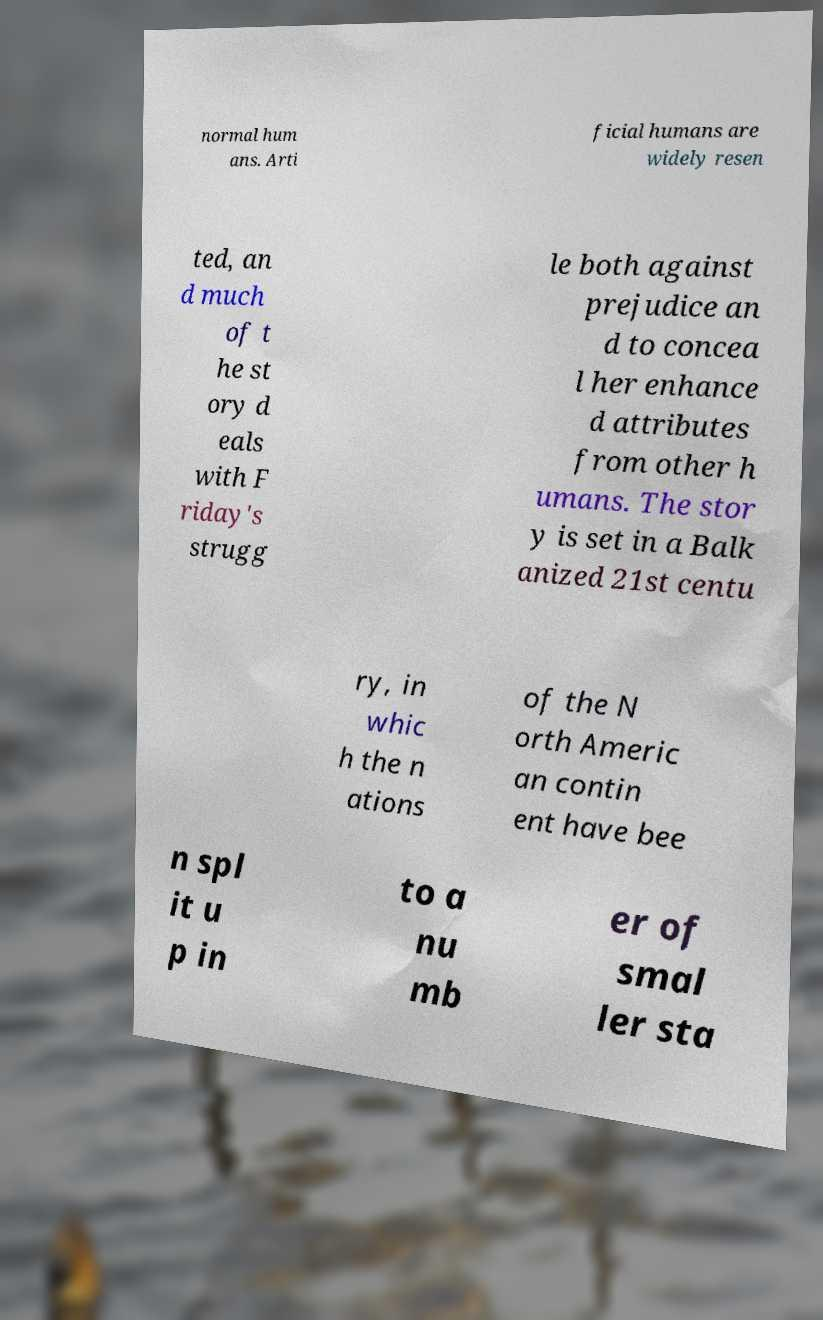Can you read and provide the text displayed in the image?This photo seems to have some interesting text. Can you extract and type it out for me? normal hum ans. Arti ficial humans are widely resen ted, an d much of t he st ory d eals with F riday's strugg le both against prejudice an d to concea l her enhance d attributes from other h umans. The stor y is set in a Balk anized 21st centu ry, in whic h the n ations of the N orth Americ an contin ent have bee n spl it u p in to a nu mb er of smal ler sta 